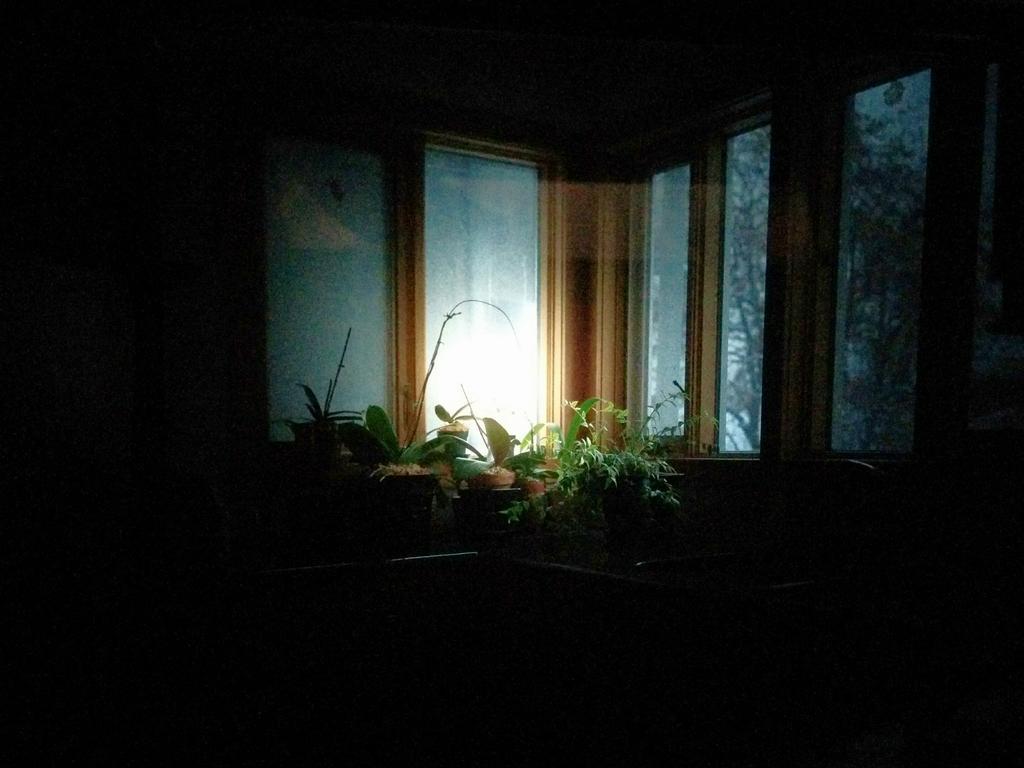How would you summarize this image in a sentence or two? In this picture I can see the inside view of a room and I can see the planets near to the windows and I see that, this picture is in dark. 